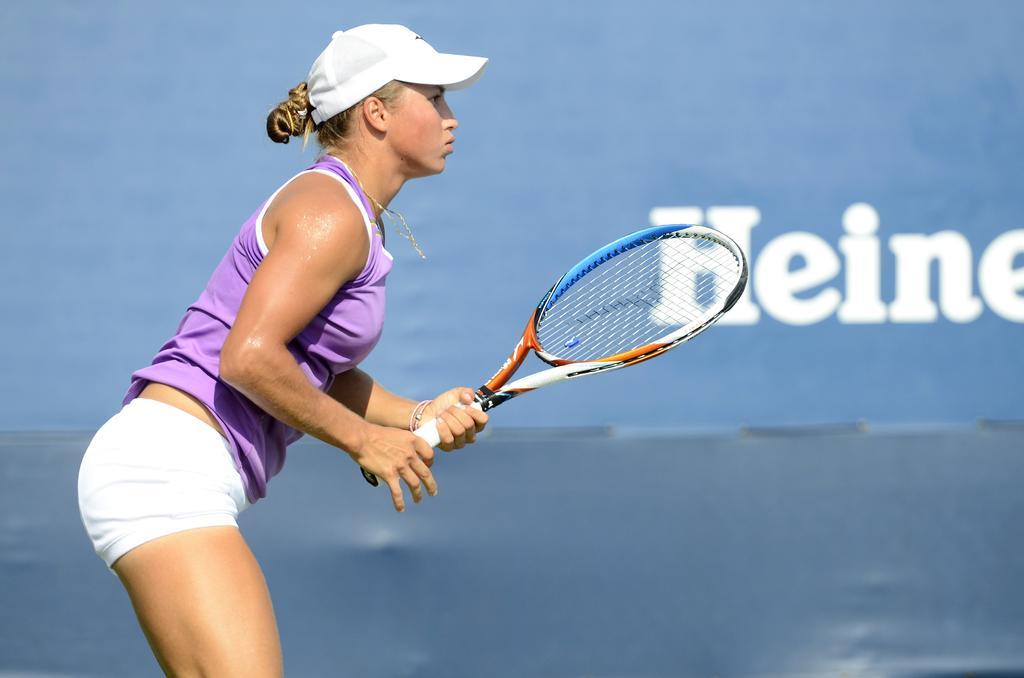Please provide a concise description of this image. On the background we can see hoarding. Here we can see a woman standing , holding a tennis racket in her hands. She wore white cap. 